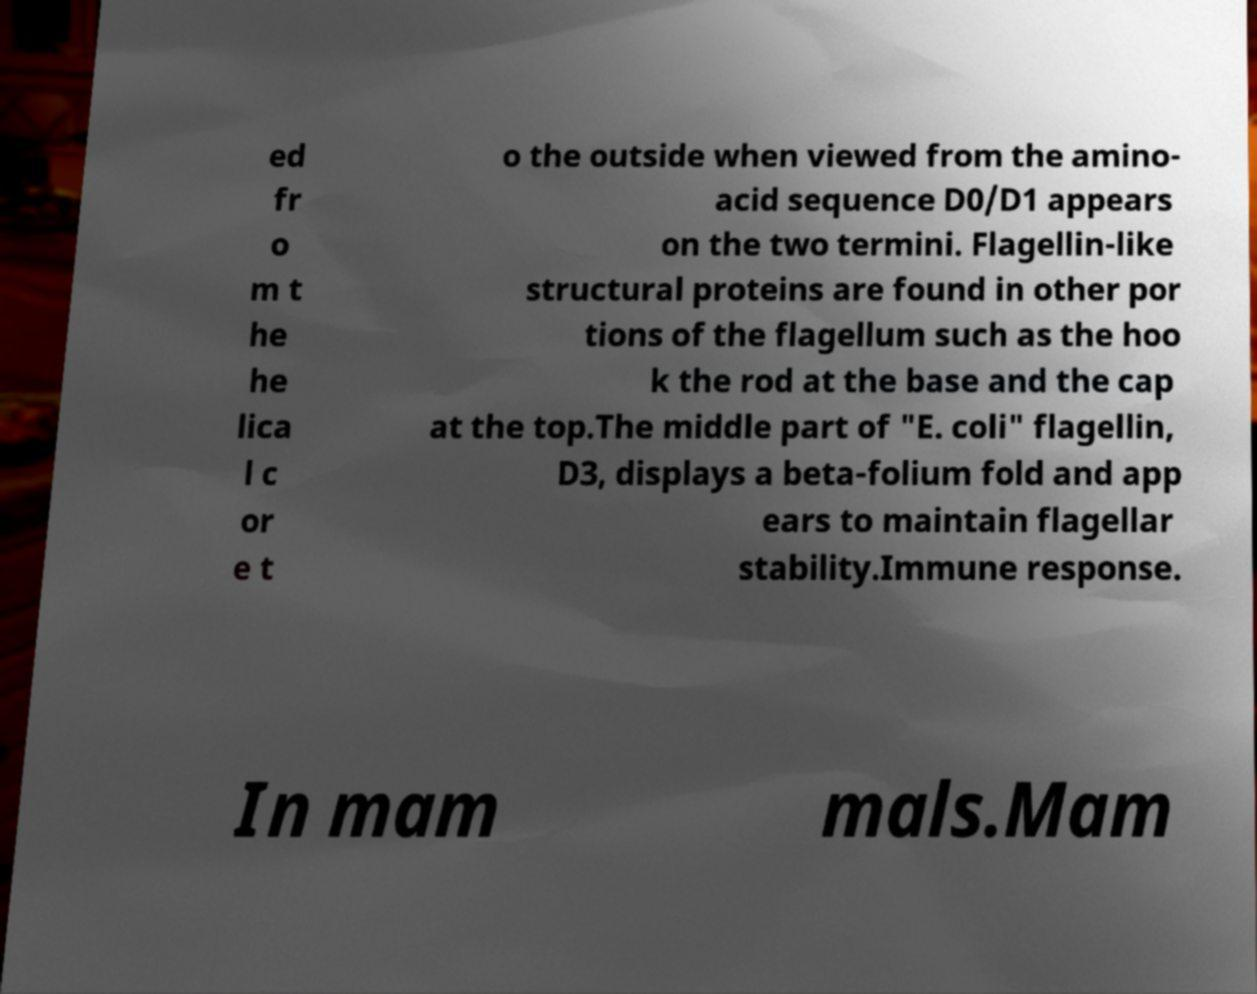Please identify and transcribe the text found in this image. ed fr o m t he he lica l c or e t o the outside when viewed from the amino- acid sequence D0/D1 appears on the two termini. Flagellin-like structural proteins are found in other por tions of the flagellum such as the hoo k the rod at the base and the cap at the top.The middle part of "E. coli" flagellin, D3, displays a beta-folium fold and app ears to maintain flagellar stability.Immune response. In mam mals.Mam 